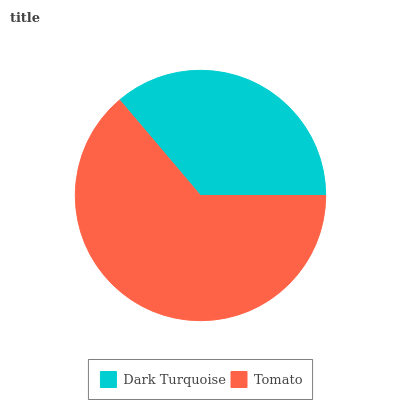Is Dark Turquoise the minimum?
Answer yes or no. Yes. Is Tomato the maximum?
Answer yes or no. Yes. Is Tomato the minimum?
Answer yes or no. No. Is Tomato greater than Dark Turquoise?
Answer yes or no. Yes. Is Dark Turquoise less than Tomato?
Answer yes or no. Yes. Is Dark Turquoise greater than Tomato?
Answer yes or no. No. Is Tomato less than Dark Turquoise?
Answer yes or no. No. Is Tomato the high median?
Answer yes or no. Yes. Is Dark Turquoise the low median?
Answer yes or no. Yes. Is Dark Turquoise the high median?
Answer yes or no. No. Is Tomato the low median?
Answer yes or no. No. 